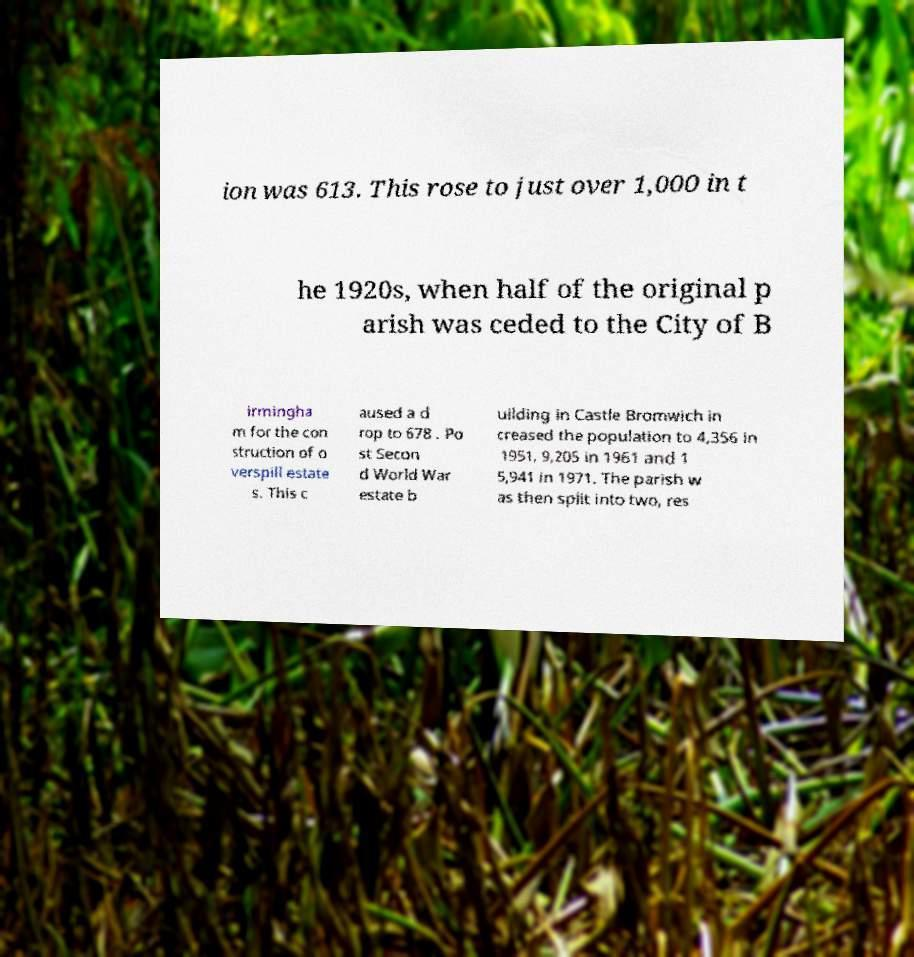What messages or text are displayed in this image? I need them in a readable, typed format. ion was 613. This rose to just over 1,000 in t he 1920s, when half of the original p arish was ceded to the City of B irmingha m for the con struction of o verspill estate s. This c aused a d rop to 678 . Po st Secon d World War estate b uilding in Castle Bromwich in creased the population to 4,356 in 1951, 9,205 in 1961 and 1 5,941 in 1971. The parish w as then split into two, res 